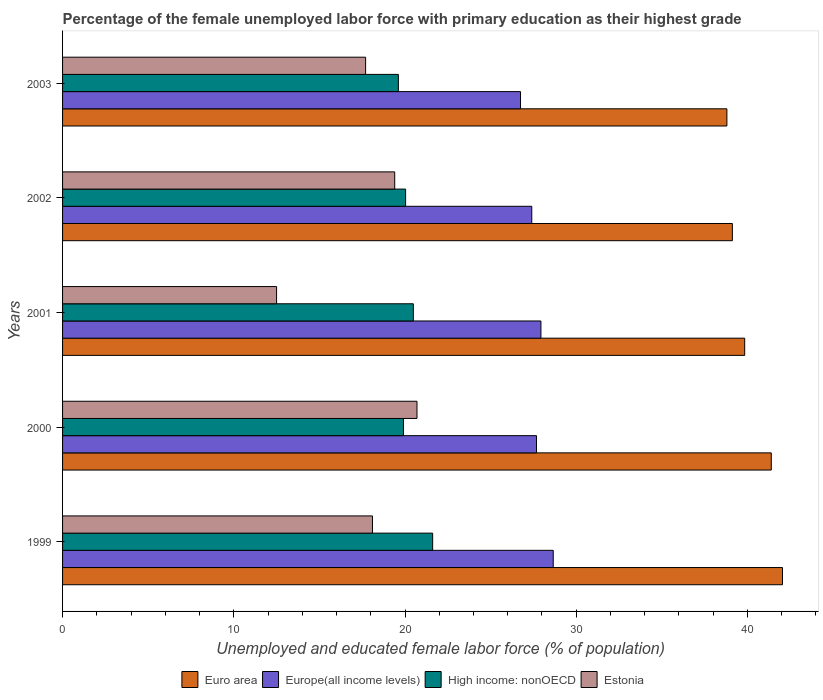How many different coloured bars are there?
Provide a succinct answer. 4. Are the number of bars per tick equal to the number of legend labels?
Your answer should be compact. Yes. Are the number of bars on each tick of the Y-axis equal?
Give a very brief answer. Yes. What is the percentage of the unemployed female labor force with primary education in Euro area in 2002?
Your answer should be very brief. 39.12. Across all years, what is the maximum percentage of the unemployed female labor force with primary education in Euro area?
Make the answer very short. 42.05. In which year was the percentage of the unemployed female labor force with primary education in High income: nonOECD maximum?
Your answer should be compact. 1999. What is the total percentage of the unemployed female labor force with primary education in High income: nonOECD in the graph?
Your answer should be very brief. 101.66. What is the difference between the percentage of the unemployed female labor force with primary education in Estonia in 2002 and that in 2003?
Your response must be concise. 1.7. What is the difference between the percentage of the unemployed female labor force with primary education in Europe(all income levels) in 2000 and the percentage of the unemployed female labor force with primary education in Euro area in 2003?
Offer a terse response. -11.12. What is the average percentage of the unemployed female labor force with primary education in Estonia per year?
Offer a very short reply. 17.68. In the year 2003, what is the difference between the percentage of the unemployed female labor force with primary education in High income: nonOECD and percentage of the unemployed female labor force with primary education in Euro area?
Make the answer very short. -19.19. In how many years, is the percentage of the unemployed female labor force with primary education in Europe(all income levels) greater than 20 %?
Offer a very short reply. 5. What is the ratio of the percentage of the unemployed female labor force with primary education in Euro area in 2000 to that in 2001?
Offer a terse response. 1.04. Is the percentage of the unemployed female labor force with primary education in High income: nonOECD in 1999 less than that in 2000?
Make the answer very short. No. Is the difference between the percentage of the unemployed female labor force with primary education in High income: nonOECD in 2001 and 2002 greater than the difference between the percentage of the unemployed female labor force with primary education in Euro area in 2001 and 2002?
Give a very brief answer. No. What is the difference between the highest and the second highest percentage of the unemployed female labor force with primary education in Euro area?
Your answer should be very brief. 0.66. What is the difference between the highest and the lowest percentage of the unemployed female labor force with primary education in Euro area?
Your response must be concise. 3.25. What does the 3rd bar from the top in 2003 represents?
Offer a very short reply. Europe(all income levels). What does the 3rd bar from the bottom in 2000 represents?
Keep it short and to the point. High income: nonOECD. How many years are there in the graph?
Your answer should be compact. 5. What is the difference between two consecutive major ticks on the X-axis?
Your answer should be very brief. 10. Are the values on the major ticks of X-axis written in scientific E-notation?
Your response must be concise. No. Does the graph contain grids?
Provide a succinct answer. No. How many legend labels are there?
Ensure brevity in your answer.  4. What is the title of the graph?
Provide a short and direct response. Percentage of the female unemployed labor force with primary education as their highest grade. What is the label or title of the X-axis?
Your response must be concise. Unemployed and educated female labor force (% of population). What is the Unemployed and educated female labor force (% of population) in Euro area in 1999?
Your response must be concise. 42.05. What is the Unemployed and educated female labor force (% of population) of Europe(all income levels) in 1999?
Provide a short and direct response. 28.66. What is the Unemployed and educated female labor force (% of population) in High income: nonOECD in 1999?
Offer a terse response. 21.62. What is the Unemployed and educated female labor force (% of population) in Estonia in 1999?
Offer a terse response. 18.1. What is the Unemployed and educated female labor force (% of population) of Euro area in 2000?
Provide a succinct answer. 41.39. What is the Unemployed and educated female labor force (% of population) in Europe(all income levels) in 2000?
Offer a very short reply. 27.68. What is the Unemployed and educated female labor force (% of population) in High income: nonOECD in 2000?
Your response must be concise. 19.91. What is the Unemployed and educated female labor force (% of population) in Estonia in 2000?
Offer a very short reply. 20.7. What is the Unemployed and educated female labor force (% of population) of Euro area in 2001?
Keep it short and to the point. 39.84. What is the Unemployed and educated female labor force (% of population) of Europe(all income levels) in 2001?
Your answer should be compact. 27.94. What is the Unemployed and educated female labor force (% of population) of High income: nonOECD in 2001?
Offer a very short reply. 20.49. What is the Unemployed and educated female labor force (% of population) of Estonia in 2001?
Make the answer very short. 12.5. What is the Unemployed and educated female labor force (% of population) of Euro area in 2002?
Keep it short and to the point. 39.12. What is the Unemployed and educated female labor force (% of population) in Europe(all income levels) in 2002?
Keep it short and to the point. 27.4. What is the Unemployed and educated female labor force (% of population) in High income: nonOECD in 2002?
Your answer should be very brief. 20.04. What is the Unemployed and educated female labor force (% of population) of Estonia in 2002?
Provide a short and direct response. 19.4. What is the Unemployed and educated female labor force (% of population) in Euro area in 2003?
Offer a terse response. 38.8. What is the Unemployed and educated female labor force (% of population) of Europe(all income levels) in 2003?
Your response must be concise. 26.75. What is the Unemployed and educated female labor force (% of population) of High income: nonOECD in 2003?
Offer a terse response. 19.61. What is the Unemployed and educated female labor force (% of population) of Estonia in 2003?
Offer a terse response. 17.7. Across all years, what is the maximum Unemployed and educated female labor force (% of population) of Euro area?
Provide a succinct answer. 42.05. Across all years, what is the maximum Unemployed and educated female labor force (% of population) of Europe(all income levels)?
Ensure brevity in your answer.  28.66. Across all years, what is the maximum Unemployed and educated female labor force (% of population) in High income: nonOECD?
Provide a succinct answer. 21.62. Across all years, what is the maximum Unemployed and educated female labor force (% of population) of Estonia?
Make the answer very short. 20.7. Across all years, what is the minimum Unemployed and educated female labor force (% of population) in Euro area?
Your answer should be very brief. 38.8. Across all years, what is the minimum Unemployed and educated female labor force (% of population) in Europe(all income levels)?
Provide a short and direct response. 26.75. Across all years, what is the minimum Unemployed and educated female labor force (% of population) of High income: nonOECD?
Offer a terse response. 19.61. Across all years, what is the minimum Unemployed and educated female labor force (% of population) in Estonia?
Provide a short and direct response. 12.5. What is the total Unemployed and educated female labor force (% of population) in Euro area in the graph?
Your answer should be very brief. 201.2. What is the total Unemployed and educated female labor force (% of population) of Europe(all income levels) in the graph?
Your answer should be very brief. 138.43. What is the total Unemployed and educated female labor force (% of population) in High income: nonOECD in the graph?
Your answer should be very brief. 101.66. What is the total Unemployed and educated female labor force (% of population) in Estonia in the graph?
Your answer should be compact. 88.4. What is the difference between the Unemployed and educated female labor force (% of population) of Euro area in 1999 and that in 2000?
Your answer should be compact. 0.66. What is the difference between the Unemployed and educated female labor force (% of population) in Europe(all income levels) in 1999 and that in 2000?
Your answer should be very brief. 0.98. What is the difference between the Unemployed and educated female labor force (% of population) of High income: nonOECD in 1999 and that in 2000?
Offer a very short reply. 1.71. What is the difference between the Unemployed and educated female labor force (% of population) of Estonia in 1999 and that in 2000?
Keep it short and to the point. -2.6. What is the difference between the Unemployed and educated female labor force (% of population) in Euro area in 1999 and that in 2001?
Offer a very short reply. 2.21. What is the difference between the Unemployed and educated female labor force (% of population) of Europe(all income levels) in 1999 and that in 2001?
Offer a very short reply. 0.72. What is the difference between the Unemployed and educated female labor force (% of population) of High income: nonOECD in 1999 and that in 2001?
Your answer should be compact. 1.13. What is the difference between the Unemployed and educated female labor force (% of population) in Estonia in 1999 and that in 2001?
Make the answer very short. 5.6. What is the difference between the Unemployed and educated female labor force (% of population) in Euro area in 1999 and that in 2002?
Give a very brief answer. 2.93. What is the difference between the Unemployed and educated female labor force (% of population) in Europe(all income levels) in 1999 and that in 2002?
Offer a terse response. 1.25. What is the difference between the Unemployed and educated female labor force (% of population) in High income: nonOECD in 1999 and that in 2002?
Your answer should be very brief. 1.58. What is the difference between the Unemployed and educated female labor force (% of population) of Estonia in 1999 and that in 2002?
Your response must be concise. -1.3. What is the difference between the Unemployed and educated female labor force (% of population) of Euro area in 1999 and that in 2003?
Offer a terse response. 3.25. What is the difference between the Unemployed and educated female labor force (% of population) in Europe(all income levels) in 1999 and that in 2003?
Ensure brevity in your answer.  1.91. What is the difference between the Unemployed and educated female labor force (% of population) of High income: nonOECD in 1999 and that in 2003?
Make the answer very short. 2. What is the difference between the Unemployed and educated female labor force (% of population) in Euro area in 2000 and that in 2001?
Offer a very short reply. 1.55. What is the difference between the Unemployed and educated female labor force (% of population) in Europe(all income levels) in 2000 and that in 2001?
Ensure brevity in your answer.  -0.26. What is the difference between the Unemployed and educated female labor force (% of population) of High income: nonOECD in 2000 and that in 2001?
Give a very brief answer. -0.58. What is the difference between the Unemployed and educated female labor force (% of population) of Euro area in 2000 and that in 2002?
Your answer should be compact. 2.27. What is the difference between the Unemployed and educated female labor force (% of population) of Europe(all income levels) in 2000 and that in 2002?
Your answer should be compact. 0.28. What is the difference between the Unemployed and educated female labor force (% of population) in High income: nonOECD in 2000 and that in 2002?
Offer a terse response. -0.13. What is the difference between the Unemployed and educated female labor force (% of population) in Euro area in 2000 and that in 2003?
Keep it short and to the point. 2.59. What is the difference between the Unemployed and educated female labor force (% of population) in Europe(all income levels) in 2000 and that in 2003?
Your answer should be compact. 0.93. What is the difference between the Unemployed and educated female labor force (% of population) in High income: nonOECD in 2000 and that in 2003?
Your answer should be very brief. 0.3. What is the difference between the Unemployed and educated female labor force (% of population) in Euro area in 2001 and that in 2002?
Your answer should be very brief. 0.72. What is the difference between the Unemployed and educated female labor force (% of population) of Europe(all income levels) in 2001 and that in 2002?
Make the answer very short. 0.53. What is the difference between the Unemployed and educated female labor force (% of population) of High income: nonOECD in 2001 and that in 2002?
Your answer should be very brief. 0.45. What is the difference between the Unemployed and educated female labor force (% of population) of Euro area in 2001 and that in 2003?
Ensure brevity in your answer.  1.04. What is the difference between the Unemployed and educated female labor force (% of population) of Europe(all income levels) in 2001 and that in 2003?
Offer a terse response. 1.19. What is the difference between the Unemployed and educated female labor force (% of population) in High income: nonOECD in 2001 and that in 2003?
Offer a terse response. 0.88. What is the difference between the Unemployed and educated female labor force (% of population) in Estonia in 2001 and that in 2003?
Make the answer very short. -5.2. What is the difference between the Unemployed and educated female labor force (% of population) of Euro area in 2002 and that in 2003?
Offer a terse response. 0.32. What is the difference between the Unemployed and educated female labor force (% of population) of Europe(all income levels) in 2002 and that in 2003?
Ensure brevity in your answer.  0.66. What is the difference between the Unemployed and educated female labor force (% of population) of High income: nonOECD in 2002 and that in 2003?
Provide a succinct answer. 0.42. What is the difference between the Unemployed and educated female labor force (% of population) of Estonia in 2002 and that in 2003?
Your answer should be very brief. 1.7. What is the difference between the Unemployed and educated female labor force (% of population) in Euro area in 1999 and the Unemployed and educated female labor force (% of population) in Europe(all income levels) in 2000?
Your answer should be very brief. 14.37. What is the difference between the Unemployed and educated female labor force (% of population) in Euro area in 1999 and the Unemployed and educated female labor force (% of population) in High income: nonOECD in 2000?
Your answer should be compact. 22.14. What is the difference between the Unemployed and educated female labor force (% of population) of Euro area in 1999 and the Unemployed and educated female labor force (% of population) of Estonia in 2000?
Offer a terse response. 21.35. What is the difference between the Unemployed and educated female labor force (% of population) of Europe(all income levels) in 1999 and the Unemployed and educated female labor force (% of population) of High income: nonOECD in 2000?
Make the answer very short. 8.75. What is the difference between the Unemployed and educated female labor force (% of population) of Europe(all income levels) in 1999 and the Unemployed and educated female labor force (% of population) of Estonia in 2000?
Ensure brevity in your answer.  7.96. What is the difference between the Unemployed and educated female labor force (% of population) in High income: nonOECD in 1999 and the Unemployed and educated female labor force (% of population) in Estonia in 2000?
Ensure brevity in your answer.  0.92. What is the difference between the Unemployed and educated female labor force (% of population) of Euro area in 1999 and the Unemployed and educated female labor force (% of population) of Europe(all income levels) in 2001?
Ensure brevity in your answer.  14.11. What is the difference between the Unemployed and educated female labor force (% of population) in Euro area in 1999 and the Unemployed and educated female labor force (% of population) in High income: nonOECD in 2001?
Offer a terse response. 21.56. What is the difference between the Unemployed and educated female labor force (% of population) in Euro area in 1999 and the Unemployed and educated female labor force (% of population) in Estonia in 2001?
Your answer should be compact. 29.55. What is the difference between the Unemployed and educated female labor force (% of population) of Europe(all income levels) in 1999 and the Unemployed and educated female labor force (% of population) of High income: nonOECD in 2001?
Provide a succinct answer. 8.17. What is the difference between the Unemployed and educated female labor force (% of population) of Europe(all income levels) in 1999 and the Unemployed and educated female labor force (% of population) of Estonia in 2001?
Give a very brief answer. 16.16. What is the difference between the Unemployed and educated female labor force (% of population) in High income: nonOECD in 1999 and the Unemployed and educated female labor force (% of population) in Estonia in 2001?
Ensure brevity in your answer.  9.12. What is the difference between the Unemployed and educated female labor force (% of population) in Euro area in 1999 and the Unemployed and educated female labor force (% of population) in Europe(all income levels) in 2002?
Your response must be concise. 14.64. What is the difference between the Unemployed and educated female labor force (% of population) of Euro area in 1999 and the Unemployed and educated female labor force (% of population) of High income: nonOECD in 2002?
Ensure brevity in your answer.  22.01. What is the difference between the Unemployed and educated female labor force (% of population) of Euro area in 1999 and the Unemployed and educated female labor force (% of population) of Estonia in 2002?
Your response must be concise. 22.65. What is the difference between the Unemployed and educated female labor force (% of population) in Europe(all income levels) in 1999 and the Unemployed and educated female labor force (% of population) in High income: nonOECD in 2002?
Ensure brevity in your answer.  8.62. What is the difference between the Unemployed and educated female labor force (% of population) of Europe(all income levels) in 1999 and the Unemployed and educated female labor force (% of population) of Estonia in 2002?
Your answer should be compact. 9.26. What is the difference between the Unemployed and educated female labor force (% of population) of High income: nonOECD in 1999 and the Unemployed and educated female labor force (% of population) of Estonia in 2002?
Offer a terse response. 2.22. What is the difference between the Unemployed and educated female labor force (% of population) in Euro area in 1999 and the Unemployed and educated female labor force (% of population) in Europe(all income levels) in 2003?
Ensure brevity in your answer.  15.3. What is the difference between the Unemployed and educated female labor force (% of population) in Euro area in 1999 and the Unemployed and educated female labor force (% of population) in High income: nonOECD in 2003?
Offer a very short reply. 22.44. What is the difference between the Unemployed and educated female labor force (% of population) of Euro area in 1999 and the Unemployed and educated female labor force (% of population) of Estonia in 2003?
Make the answer very short. 24.35. What is the difference between the Unemployed and educated female labor force (% of population) in Europe(all income levels) in 1999 and the Unemployed and educated female labor force (% of population) in High income: nonOECD in 2003?
Offer a terse response. 9.05. What is the difference between the Unemployed and educated female labor force (% of population) of Europe(all income levels) in 1999 and the Unemployed and educated female labor force (% of population) of Estonia in 2003?
Give a very brief answer. 10.96. What is the difference between the Unemployed and educated female labor force (% of population) of High income: nonOECD in 1999 and the Unemployed and educated female labor force (% of population) of Estonia in 2003?
Make the answer very short. 3.92. What is the difference between the Unemployed and educated female labor force (% of population) in Euro area in 2000 and the Unemployed and educated female labor force (% of population) in Europe(all income levels) in 2001?
Provide a succinct answer. 13.45. What is the difference between the Unemployed and educated female labor force (% of population) of Euro area in 2000 and the Unemployed and educated female labor force (% of population) of High income: nonOECD in 2001?
Provide a succinct answer. 20.91. What is the difference between the Unemployed and educated female labor force (% of population) in Euro area in 2000 and the Unemployed and educated female labor force (% of population) in Estonia in 2001?
Your answer should be compact. 28.89. What is the difference between the Unemployed and educated female labor force (% of population) in Europe(all income levels) in 2000 and the Unemployed and educated female labor force (% of population) in High income: nonOECD in 2001?
Offer a very short reply. 7.19. What is the difference between the Unemployed and educated female labor force (% of population) in Europe(all income levels) in 2000 and the Unemployed and educated female labor force (% of population) in Estonia in 2001?
Your answer should be compact. 15.18. What is the difference between the Unemployed and educated female labor force (% of population) in High income: nonOECD in 2000 and the Unemployed and educated female labor force (% of population) in Estonia in 2001?
Your answer should be compact. 7.41. What is the difference between the Unemployed and educated female labor force (% of population) of Euro area in 2000 and the Unemployed and educated female labor force (% of population) of Europe(all income levels) in 2002?
Offer a terse response. 13.99. What is the difference between the Unemployed and educated female labor force (% of population) of Euro area in 2000 and the Unemployed and educated female labor force (% of population) of High income: nonOECD in 2002?
Your answer should be compact. 21.36. What is the difference between the Unemployed and educated female labor force (% of population) of Euro area in 2000 and the Unemployed and educated female labor force (% of population) of Estonia in 2002?
Make the answer very short. 21.99. What is the difference between the Unemployed and educated female labor force (% of population) of Europe(all income levels) in 2000 and the Unemployed and educated female labor force (% of population) of High income: nonOECD in 2002?
Offer a terse response. 7.64. What is the difference between the Unemployed and educated female labor force (% of population) in Europe(all income levels) in 2000 and the Unemployed and educated female labor force (% of population) in Estonia in 2002?
Your answer should be compact. 8.28. What is the difference between the Unemployed and educated female labor force (% of population) in High income: nonOECD in 2000 and the Unemployed and educated female labor force (% of population) in Estonia in 2002?
Make the answer very short. 0.51. What is the difference between the Unemployed and educated female labor force (% of population) of Euro area in 2000 and the Unemployed and educated female labor force (% of population) of Europe(all income levels) in 2003?
Ensure brevity in your answer.  14.65. What is the difference between the Unemployed and educated female labor force (% of population) in Euro area in 2000 and the Unemployed and educated female labor force (% of population) in High income: nonOECD in 2003?
Offer a terse response. 21.78. What is the difference between the Unemployed and educated female labor force (% of population) of Euro area in 2000 and the Unemployed and educated female labor force (% of population) of Estonia in 2003?
Your answer should be very brief. 23.69. What is the difference between the Unemployed and educated female labor force (% of population) in Europe(all income levels) in 2000 and the Unemployed and educated female labor force (% of population) in High income: nonOECD in 2003?
Your response must be concise. 8.07. What is the difference between the Unemployed and educated female labor force (% of population) of Europe(all income levels) in 2000 and the Unemployed and educated female labor force (% of population) of Estonia in 2003?
Keep it short and to the point. 9.98. What is the difference between the Unemployed and educated female labor force (% of population) in High income: nonOECD in 2000 and the Unemployed and educated female labor force (% of population) in Estonia in 2003?
Your answer should be compact. 2.21. What is the difference between the Unemployed and educated female labor force (% of population) in Euro area in 2001 and the Unemployed and educated female labor force (% of population) in Europe(all income levels) in 2002?
Give a very brief answer. 12.44. What is the difference between the Unemployed and educated female labor force (% of population) in Euro area in 2001 and the Unemployed and educated female labor force (% of population) in High income: nonOECD in 2002?
Make the answer very short. 19.8. What is the difference between the Unemployed and educated female labor force (% of population) in Euro area in 2001 and the Unemployed and educated female labor force (% of population) in Estonia in 2002?
Ensure brevity in your answer.  20.44. What is the difference between the Unemployed and educated female labor force (% of population) of Europe(all income levels) in 2001 and the Unemployed and educated female labor force (% of population) of High income: nonOECD in 2002?
Provide a short and direct response. 7.9. What is the difference between the Unemployed and educated female labor force (% of population) in Europe(all income levels) in 2001 and the Unemployed and educated female labor force (% of population) in Estonia in 2002?
Give a very brief answer. 8.54. What is the difference between the Unemployed and educated female labor force (% of population) of High income: nonOECD in 2001 and the Unemployed and educated female labor force (% of population) of Estonia in 2002?
Offer a very short reply. 1.09. What is the difference between the Unemployed and educated female labor force (% of population) of Euro area in 2001 and the Unemployed and educated female labor force (% of population) of Europe(all income levels) in 2003?
Keep it short and to the point. 13.09. What is the difference between the Unemployed and educated female labor force (% of population) of Euro area in 2001 and the Unemployed and educated female labor force (% of population) of High income: nonOECD in 2003?
Your answer should be compact. 20.23. What is the difference between the Unemployed and educated female labor force (% of population) of Euro area in 2001 and the Unemployed and educated female labor force (% of population) of Estonia in 2003?
Provide a succinct answer. 22.14. What is the difference between the Unemployed and educated female labor force (% of population) in Europe(all income levels) in 2001 and the Unemployed and educated female labor force (% of population) in High income: nonOECD in 2003?
Give a very brief answer. 8.33. What is the difference between the Unemployed and educated female labor force (% of population) of Europe(all income levels) in 2001 and the Unemployed and educated female labor force (% of population) of Estonia in 2003?
Offer a terse response. 10.24. What is the difference between the Unemployed and educated female labor force (% of population) in High income: nonOECD in 2001 and the Unemployed and educated female labor force (% of population) in Estonia in 2003?
Ensure brevity in your answer.  2.79. What is the difference between the Unemployed and educated female labor force (% of population) in Euro area in 2002 and the Unemployed and educated female labor force (% of population) in Europe(all income levels) in 2003?
Your answer should be very brief. 12.37. What is the difference between the Unemployed and educated female labor force (% of population) of Euro area in 2002 and the Unemployed and educated female labor force (% of population) of High income: nonOECD in 2003?
Your answer should be compact. 19.51. What is the difference between the Unemployed and educated female labor force (% of population) in Euro area in 2002 and the Unemployed and educated female labor force (% of population) in Estonia in 2003?
Provide a short and direct response. 21.42. What is the difference between the Unemployed and educated female labor force (% of population) of Europe(all income levels) in 2002 and the Unemployed and educated female labor force (% of population) of High income: nonOECD in 2003?
Ensure brevity in your answer.  7.79. What is the difference between the Unemployed and educated female labor force (% of population) in Europe(all income levels) in 2002 and the Unemployed and educated female labor force (% of population) in Estonia in 2003?
Give a very brief answer. 9.7. What is the difference between the Unemployed and educated female labor force (% of population) of High income: nonOECD in 2002 and the Unemployed and educated female labor force (% of population) of Estonia in 2003?
Your response must be concise. 2.34. What is the average Unemployed and educated female labor force (% of population) in Euro area per year?
Ensure brevity in your answer.  40.24. What is the average Unemployed and educated female labor force (% of population) in Europe(all income levels) per year?
Keep it short and to the point. 27.69. What is the average Unemployed and educated female labor force (% of population) of High income: nonOECD per year?
Make the answer very short. 20.33. What is the average Unemployed and educated female labor force (% of population) of Estonia per year?
Provide a succinct answer. 17.68. In the year 1999, what is the difference between the Unemployed and educated female labor force (% of population) of Euro area and Unemployed and educated female labor force (% of population) of Europe(all income levels)?
Your response must be concise. 13.39. In the year 1999, what is the difference between the Unemployed and educated female labor force (% of population) of Euro area and Unemployed and educated female labor force (% of population) of High income: nonOECD?
Keep it short and to the point. 20.43. In the year 1999, what is the difference between the Unemployed and educated female labor force (% of population) in Euro area and Unemployed and educated female labor force (% of population) in Estonia?
Your response must be concise. 23.95. In the year 1999, what is the difference between the Unemployed and educated female labor force (% of population) of Europe(all income levels) and Unemployed and educated female labor force (% of population) of High income: nonOECD?
Your answer should be compact. 7.04. In the year 1999, what is the difference between the Unemployed and educated female labor force (% of population) of Europe(all income levels) and Unemployed and educated female labor force (% of population) of Estonia?
Keep it short and to the point. 10.56. In the year 1999, what is the difference between the Unemployed and educated female labor force (% of population) of High income: nonOECD and Unemployed and educated female labor force (% of population) of Estonia?
Offer a very short reply. 3.52. In the year 2000, what is the difference between the Unemployed and educated female labor force (% of population) in Euro area and Unemployed and educated female labor force (% of population) in Europe(all income levels)?
Ensure brevity in your answer.  13.71. In the year 2000, what is the difference between the Unemployed and educated female labor force (% of population) in Euro area and Unemployed and educated female labor force (% of population) in High income: nonOECD?
Your answer should be very brief. 21.48. In the year 2000, what is the difference between the Unemployed and educated female labor force (% of population) of Euro area and Unemployed and educated female labor force (% of population) of Estonia?
Offer a terse response. 20.69. In the year 2000, what is the difference between the Unemployed and educated female labor force (% of population) in Europe(all income levels) and Unemployed and educated female labor force (% of population) in High income: nonOECD?
Keep it short and to the point. 7.77. In the year 2000, what is the difference between the Unemployed and educated female labor force (% of population) in Europe(all income levels) and Unemployed and educated female labor force (% of population) in Estonia?
Provide a short and direct response. 6.98. In the year 2000, what is the difference between the Unemployed and educated female labor force (% of population) in High income: nonOECD and Unemployed and educated female labor force (% of population) in Estonia?
Make the answer very short. -0.79. In the year 2001, what is the difference between the Unemployed and educated female labor force (% of population) in Euro area and Unemployed and educated female labor force (% of population) in Europe(all income levels)?
Provide a short and direct response. 11.9. In the year 2001, what is the difference between the Unemployed and educated female labor force (% of population) of Euro area and Unemployed and educated female labor force (% of population) of High income: nonOECD?
Your answer should be compact. 19.35. In the year 2001, what is the difference between the Unemployed and educated female labor force (% of population) in Euro area and Unemployed and educated female labor force (% of population) in Estonia?
Provide a short and direct response. 27.34. In the year 2001, what is the difference between the Unemployed and educated female labor force (% of population) of Europe(all income levels) and Unemployed and educated female labor force (% of population) of High income: nonOECD?
Your response must be concise. 7.45. In the year 2001, what is the difference between the Unemployed and educated female labor force (% of population) of Europe(all income levels) and Unemployed and educated female labor force (% of population) of Estonia?
Offer a very short reply. 15.44. In the year 2001, what is the difference between the Unemployed and educated female labor force (% of population) in High income: nonOECD and Unemployed and educated female labor force (% of population) in Estonia?
Offer a terse response. 7.99. In the year 2002, what is the difference between the Unemployed and educated female labor force (% of population) of Euro area and Unemployed and educated female labor force (% of population) of Europe(all income levels)?
Ensure brevity in your answer.  11.72. In the year 2002, what is the difference between the Unemployed and educated female labor force (% of population) of Euro area and Unemployed and educated female labor force (% of population) of High income: nonOECD?
Ensure brevity in your answer.  19.09. In the year 2002, what is the difference between the Unemployed and educated female labor force (% of population) in Euro area and Unemployed and educated female labor force (% of population) in Estonia?
Offer a very short reply. 19.72. In the year 2002, what is the difference between the Unemployed and educated female labor force (% of population) in Europe(all income levels) and Unemployed and educated female labor force (% of population) in High income: nonOECD?
Offer a very short reply. 7.37. In the year 2002, what is the difference between the Unemployed and educated female labor force (% of population) in Europe(all income levels) and Unemployed and educated female labor force (% of population) in Estonia?
Provide a short and direct response. 8. In the year 2002, what is the difference between the Unemployed and educated female labor force (% of population) in High income: nonOECD and Unemployed and educated female labor force (% of population) in Estonia?
Offer a terse response. 0.64. In the year 2003, what is the difference between the Unemployed and educated female labor force (% of population) in Euro area and Unemployed and educated female labor force (% of population) in Europe(all income levels)?
Your answer should be very brief. 12.05. In the year 2003, what is the difference between the Unemployed and educated female labor force (% of population) of Euro area and Unemployed and educated female labor force (% of population) of High income: nonOECD?
Give a very brief answer. 19.19. In the year 2003, what is the difference between the Unemployed and educated female labor force (% of population) of Euro area and Unemployed and educated female labor force (% of population) of Estonia?
Your answer should be very brief. 21.1. In the year 2003, what is the difference between the Unemployed and educated female labor force (% of population) of Europe(all income levels) and Unemployed and educated female labor force (% of population) of High income: nonOECD?
Your answer should be very brief. 7.13. In the year 2003, what is the difference between the Unemployed and educated female labor force (% of population) in Europe(all income levels) and Unemployed and educated female labor force (% of population) in Estonia?
Offer a very short reply. 9.05. In the year 2003, what is the difference between the Unemployed and educated female labor force (% of population) in High income: nonOECD and Unemployed and educated female labor force (% of population) in Estonia?
Ensure brevity in your answer.  1.91. What is the ratio of the Unemployed and educated female labor force (% of population) of Euro area in 1999 to that in 2000?
Your response must be concise. 1.02. What is the ratio of the Unemployed and educated female labor force (% of population) of Europe(all income levels) in 1999 to that in 2000?
Your answer should be very brief. 1.04. What is the ratio of the Unemployed and educated female labor force (% of population) of High income: nonOECD in 1999 to that in 2000?
Your answer should be very brief. 1.09. What is the ratio of the Unemployed and educated female labor force (% of population) in Estonia in 1999 to that in 2000?
Your answer should be compact. 0.87. What is the ratio of the Unemployed and educated female labor force (% of population) of Euro area in 1999 to that in 2001?
Ensure brevity in your answer.  1.06. What is the ratio of the Unemployed and educated female labor force (% of population) in Europe(all income levels) in 1999 to that in 2001?
Offer a very short reply. 1.03. What is the ratio of the Unemployed and educated female labor force (% of population) of High income: nonOECD in 1999 to that in 2001?
Your answer should be compact. 1.06. What is the ratio of the Unemployed and educated female labor force (% of population) in Estonia in 1999 to that in 2001?
Make the answer very short. 1.45. What is the ratio of the Unemployed and educated female labor force (% of population) in Euro area in 1999 to that in 2002?
Your answer should be very brief. 1.07. What is the ratio of the Unemployed and educated female labor force (% of population) of Europe(all income levels) in 1999 to that in 2002?
Make the answer very short. 1.05. What is the ratio of the Unemployed and educated female labor force (% of population) of High income: nonOECD in 1999 to that in 2002?
Provide a succinct answer. 1.08. What is the ratio of the Unemployed and educated female labor force (% of population) in Estonia in 1999 to that in 2002?
Make the answer very short. 0.93. What is the ratio of the Unemployed and educated female labor force (% of population) in Euro area in 1999 to that in 2003?
Make the answer very short. 1.08. What is the ratio of the Unemployed and educated female labor force (% of population) in Europe(all income levels) in 1999 to that in 2003?
Offer a terse response. 1.07. What is the ratio of the Unemployed and educated female labor force (% of population) of High income: nonOECD in 1999 to that in 2003?
Give a very brief answer. 1.1. What is the ratio of the Unemployed and educated female labor force (% of population) of Estonia in 1999 to that in 2003?
Provide a succinct answer. 1.02. What is the ratio of the Unemployed and educated female labor force (% of population) of Euro area in 2000 to that in 2001?
Offer a very short reply. 1.04. What is the ratio of the Unemployed and educated female labor force (% of population) in High income: nonOECD in 2000 to that in 2001?
Your answer should be very brief. 0.97. What is the ratio of the Unemployed and educated female labor force (% of population) of Estonia in 2000 to that in 2001?
Your response must be concise. 1.66. What is the ratio of the Unemployed and educated female labor force (% of population) of Euro area in 2000 to that in 2002?
Provide a short and direct response. 1.06. What is the ratio of the Unemployed and educated female labor force (% of population) of Estonia in 2000 to that in 2002?
Provide a succinct answer. 1.07. What is the ratio of the Unemployed and educated female labor force (% of population) of Euro area in 2000 to that in 2003?
Give a very brief answer. 1.07. What is the ratio of the Unemployed and educated female labor force (% of population) in Europe(all income levels) in 2000 to that in 2003?
Give a very brief answer. 1.03. What is the ratio of the Unemployed and educated female labor force (% of population) of High income: nonOECD in 2000 to that in 2003?
Make the answer very short. 1.02. What is the ratio of the Unemployed and educated female labor force (% of population) of Estonia in 2000 to that in 2003?
Provide a short and direct response. 1.17. What is the ratio of the Unemployed and educated female labor force (% of population) of Euro area in 2001 to that in 2002?
Offer a terse response. 1.02. What is the ratio of the Unemployed and educated female labor force (% of population) of Europe(all income levels) in 2001 to that in 2002?
Keep it short and to the point. 1.02. What is the ratio of the Unemployed and educated female labor force (% of population) of High income: nonOECD in 2001 to that in 2002?
Ensure brevity in your answer.  1.02. What is the ratio of the Unemployed and educated female labor force (% of population) in Estonia in 2001 to that in 2002?
Provide a succinct answer. 0.64. What is the ratio of the Unemployed and educated female labor force (% of population) in Euro area in 2001 to that in 2003?
Your answer should be very brief. 1.03. What is the ratio of the Unemployed and educated female labor force (% of population) of Europe(all income levels) in 2001 to that in 2003?
Provide a succinct answer. 1.04. What is the ratio of the Unemployed and educated female labor force (% of population) in High income: nonOECD in 2001 to that in 2003?
Make the answer very short. 1.04. What is the ratio of the Unemployed and educated female labor force (% of population) in Estonia in 2001 to that in 2003?
Offer a very short reply. 0.71. What is the ratio of the Unemployed and educated female labor force (% of population) in Euro area in 2002 to that in 2003?
Offer a terse response. 1.01. What is the ratio of the Unemployed and educated female labor force (% of population) of Europe(all income levels) in 2002 to that in 2003?
Ensure brevity in your answer.  1.02. What is the ratio of the Unemployed and educated female labor force (% of population) of High income: nonOECD in 2002 to that in 2003?
Give a very brief answer. 1.02. What is the ratio of the Unemployed and educated female labor force (% of population) of Estonia in 2002 to that in 2003?
Your answer should be compact. 1.1. What is the difference between the highest and the second highest Unemployed and educated female labor force (% of population) of Euro area?
Keep it short and to the point. 0.66. What is the difference between the highest and the second highest Unemployed and educated female labor force (% of population) of Europe(all income levels)?
Offer a terse response. 0.72. What is the difference between the highest and the second highest Unemployed and educated female labor force (% of population) in High income: nonOECD?
Ensure brevity in your answer.  1.13. What is the difference between the highest and the second highest Unemployed and educated female labor force (% of population) of Estonia?
Offer a terse response. 1.3. What is the difference between the highest and the lowest Unemployed and educated female labor force (% of population) of Euro area?
Offer a terse response. 3.25. What is the difference between the highest and the lowest Unemployed and educated female labor force (% of population) of Europe(all income levels)?
Give a very brief answer. 1.91. What is the difference between the highest and the lowest Unemployed and educated female labor force (% of population) in High income: nonOECD?
Offer a terse response. 2. What is the difference between the highest and the lowest Unemployed and educated female labor force (% of population) of Estonia?
Provide a short and direct response. 8.2. 